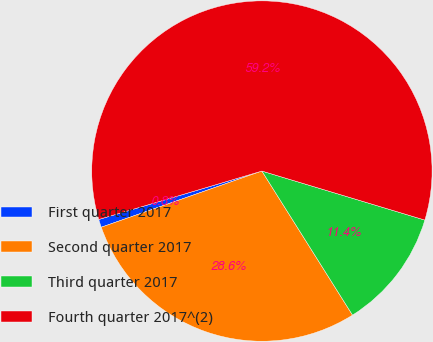Convert chart. <chart><loc_0><loc_0><loc_500><loc_500><pie_chart><fcel>First quarter 2017<fcel>Second quarter 2017<fcel>Third quarter 2017<fcel>Fourth quarter 2017^(2)<nl><fcel>0.76%<fcel>28.58%<fcel>11.41%<fcel>59.24%<nl></chart> 